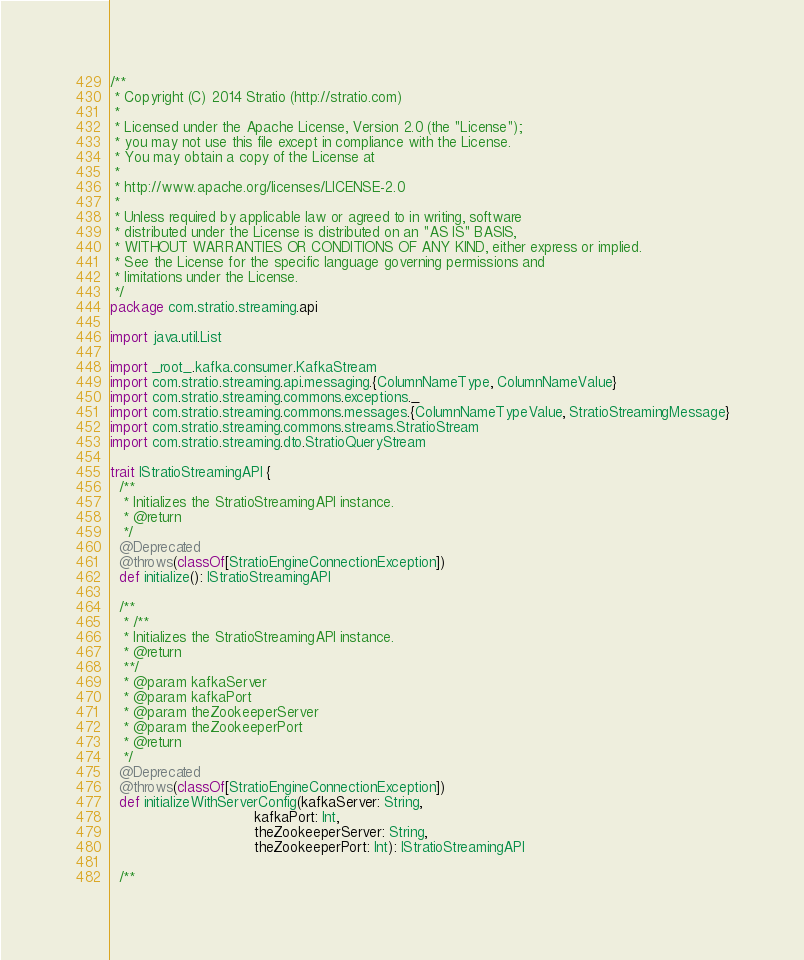<code> <loc_0><loc_0><loc_500><loc_500><_Scala_>/**
 * Copyright (C) 2014 Stratio (http://stratio.com)
 *
 * Licensed under the Apache License, Version 2.0 (the "License");
 * you may not use this file except in compliance with the License.
 * You may obtain a copy of the License at
 *
 * http://www.apache.org/licenses/LICENSE-2.0
 *
 * Unless required by applicable law or agreed to in writing, software
 * distributed under the License is distributed on an "AS IS" BASIS,
 * WITHOUT WARRANTIES OR CONDITIONS OF ANY KIND, either express or implied.
 * See the License for the specific language governing permissions and
 * limitations under the License.
 */
package com.stratio.streaming.api

import java.util.List

import _root_.kafka.consumer.KafkaStream
import com.stratio.streaming.api.messaging.{ColumnNameType, ColumnNameValue}
import com.stratio.streaming.commons.exceptions._
import com.stratio.streaming.commons.messages.{ColumnNameTypeValue, StratioStreamingMessage}
import com.stratio.streaming.commons.streams.StratioStream
import com.stratio.streaming.dto.StratioQueryStream

trait IStratioStreamingAPI {
  /**
   * Initializes the StratioStreamingAPI instance.
   * @return
   */
  @Deprecated
  @throws(classOf[StratioEngineConnectionException])
  def initialize(): IStratioStreamingAPI

  /**
   * /**
   * Initializes the StratioStreamingAPI instance.
   * @return
   **/
   * @param kafkaServer
   * @param kafkaPort
   * @param theZookeeperServer
   * @param theZookeeperPort
   * @return
   */
  @Deprecated
  @throws(classOf[StratioEngineConnectionException])
  def initializeWithServerConfig(kafkaServer: String,
                                 kafkaPort: Int,
                                 theZookeeperServer: String,
                                 theZookeeperPort: Int): IStratioStreamingAPI

  /**</code> 